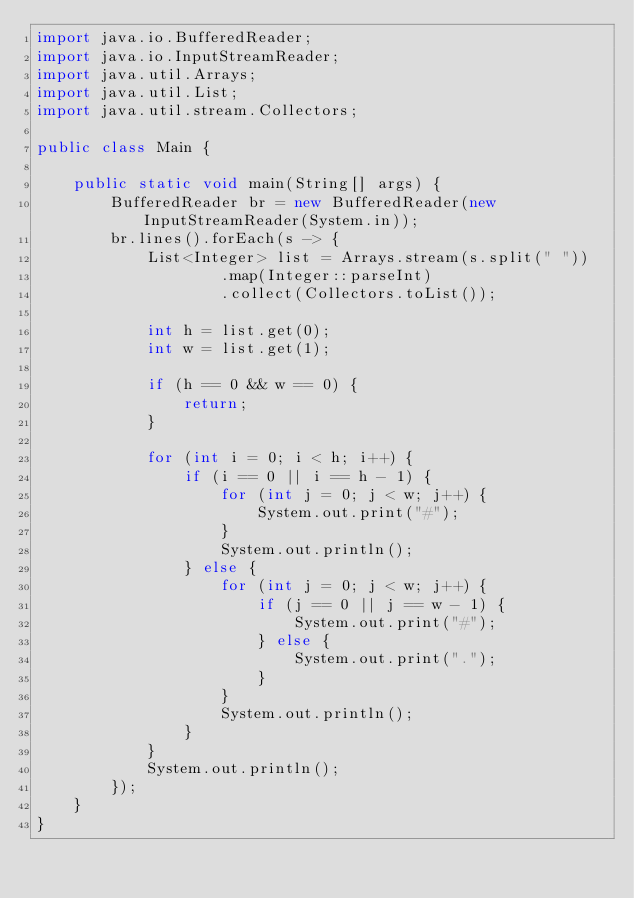<code> <loc_0><loc_0><loc_500><loc_500><_Java_>import java.io.BufferedReader;
import java.io.InputStreamReader;
import java.util.Arrays;
import java.util.List;
import java.util.stream.Collectors;

public class Main {

    public static void main(String[] args) {
        BufferedReader br = new BufferedReader(new InputStreamReader(System.in));
        br.lines().forEach(s -> {
            List<Integer> list = Arrays.stream(s.split(" "))
                    .map(Integer::parseInt)
                    .collect(Collectors.toList());

            int h = list.get(0);
            int w = list.get(1);

            if (h == 0 && w == 0) {
                return;
            }

            for (int i = 0; i < h; i++) {
                if (i == 0 || i == h - 1) {
                    for (int j = 0; j < w; j++) {
                        System.out.print("#");
                    }
                    System.out.println();
                } else {
                    for (int j = 0; j < w; j++) {
                        if (j == 0 || j == w - 1) {
                            System.out.print("#");
                        } else {
                            System.out.print(".");
                        }
                    }
                    System.out.println();
                }
            }
            System.out.println();
        });
    }
}</code> 